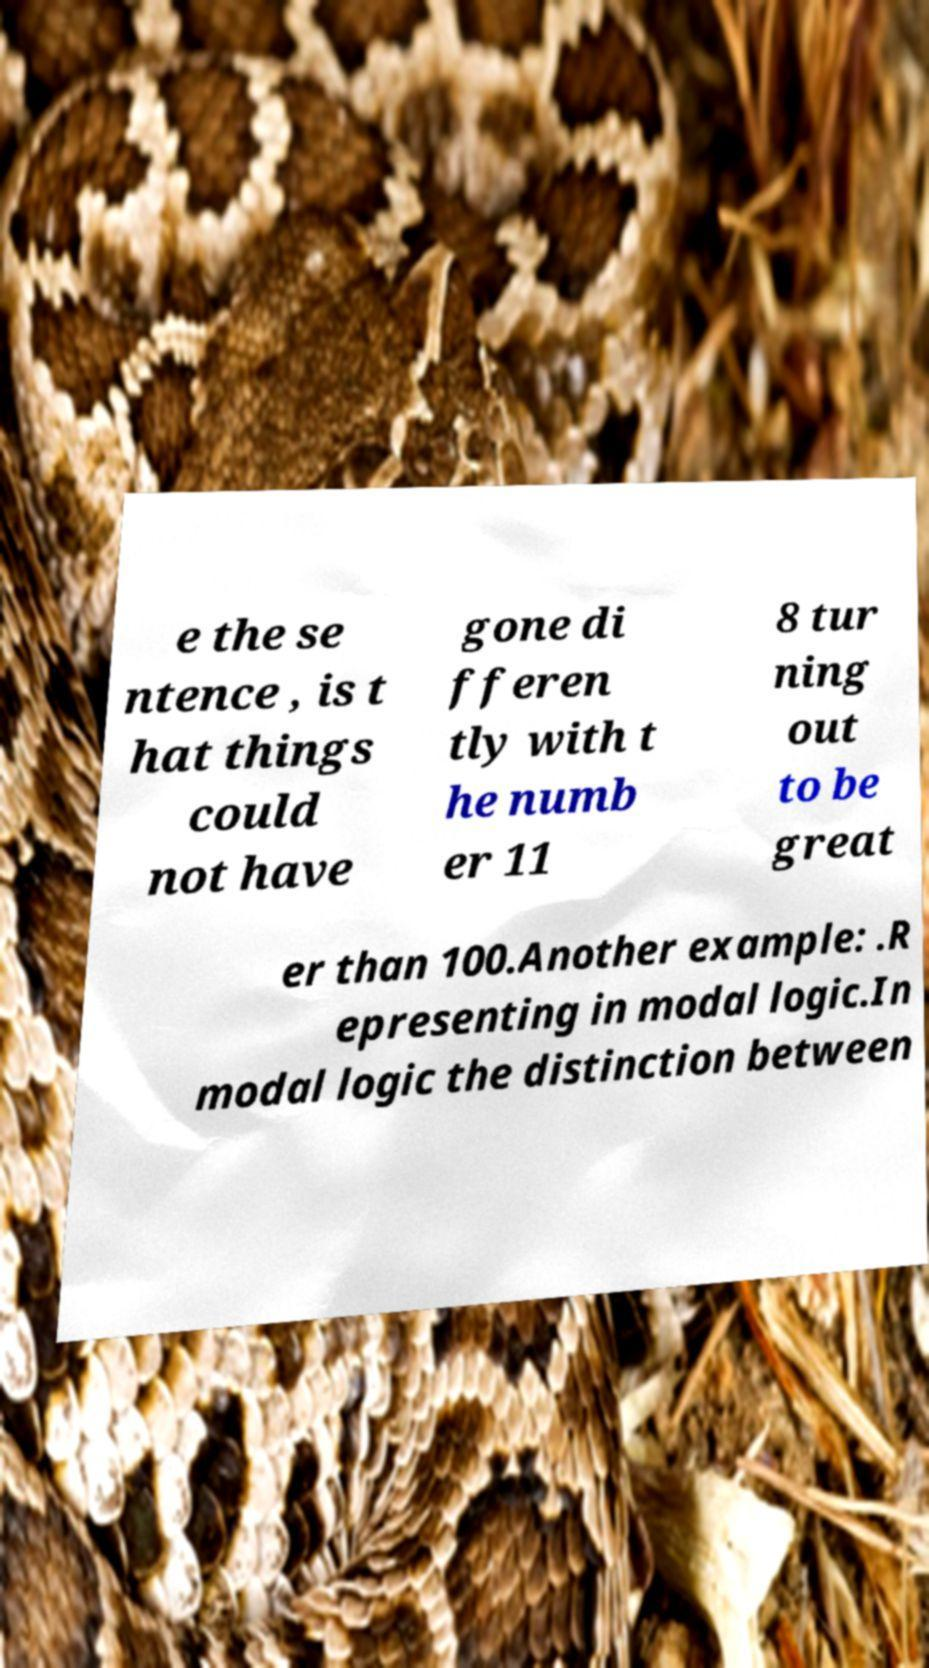Please identify and transcribe the text found in this image. e the se ntence , is t hat things could not have gone di fferen tly with t he numb er 11 8 tur ning out to be great er than 100.Another example: .R epresenting in modal logic.In modal logic the distinction between 